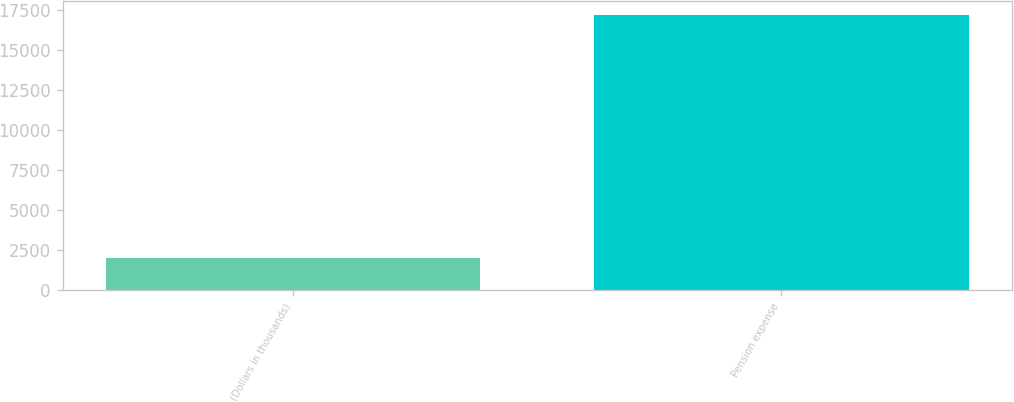<chart> <loc_0><loc_0><loc_500><loc_500><bar_chart><fcel>(Dollars in thousands)<fcel>Pension expense<nl><fcel>2016<fcel>17188<nl></chart> 